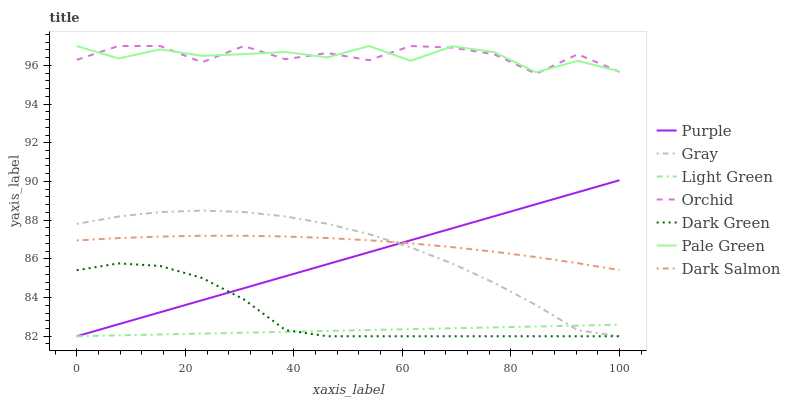Does Light Green have the minimum area under the curve?
Answer yes or no. Yes. Does Orchid have the maximum area under the curve?
Answer yes or no. Yes. Does Purple have the minimum area under the curve?
Answer yes or no. No. Does Purple have the maximum area under the curve?
Answer yes or no. No. Is Purple the smoothest?
Answer yes or no. Yes. Is Orchid the roughest?
Answer yes or no. Yes. Is Dark Salmon the smoothest?
Answer yes or no. No. Is Dark Salmon the roughest?
Answer yes or no. No. Does Dark Salmon have the lowest value?
Answer yes or no. No. Does Orchid have the highest value?
Answer yes or no. Yes. Does Purple have the highest value?
Answer yes or no. No. Is Purple less than Pale Green?
Answer yes or no. Yes. Is Orchid greater than Purple?
Answer yes or no. Yes. Does Purple intersect Pale Green?
Answer yes or no. No. 